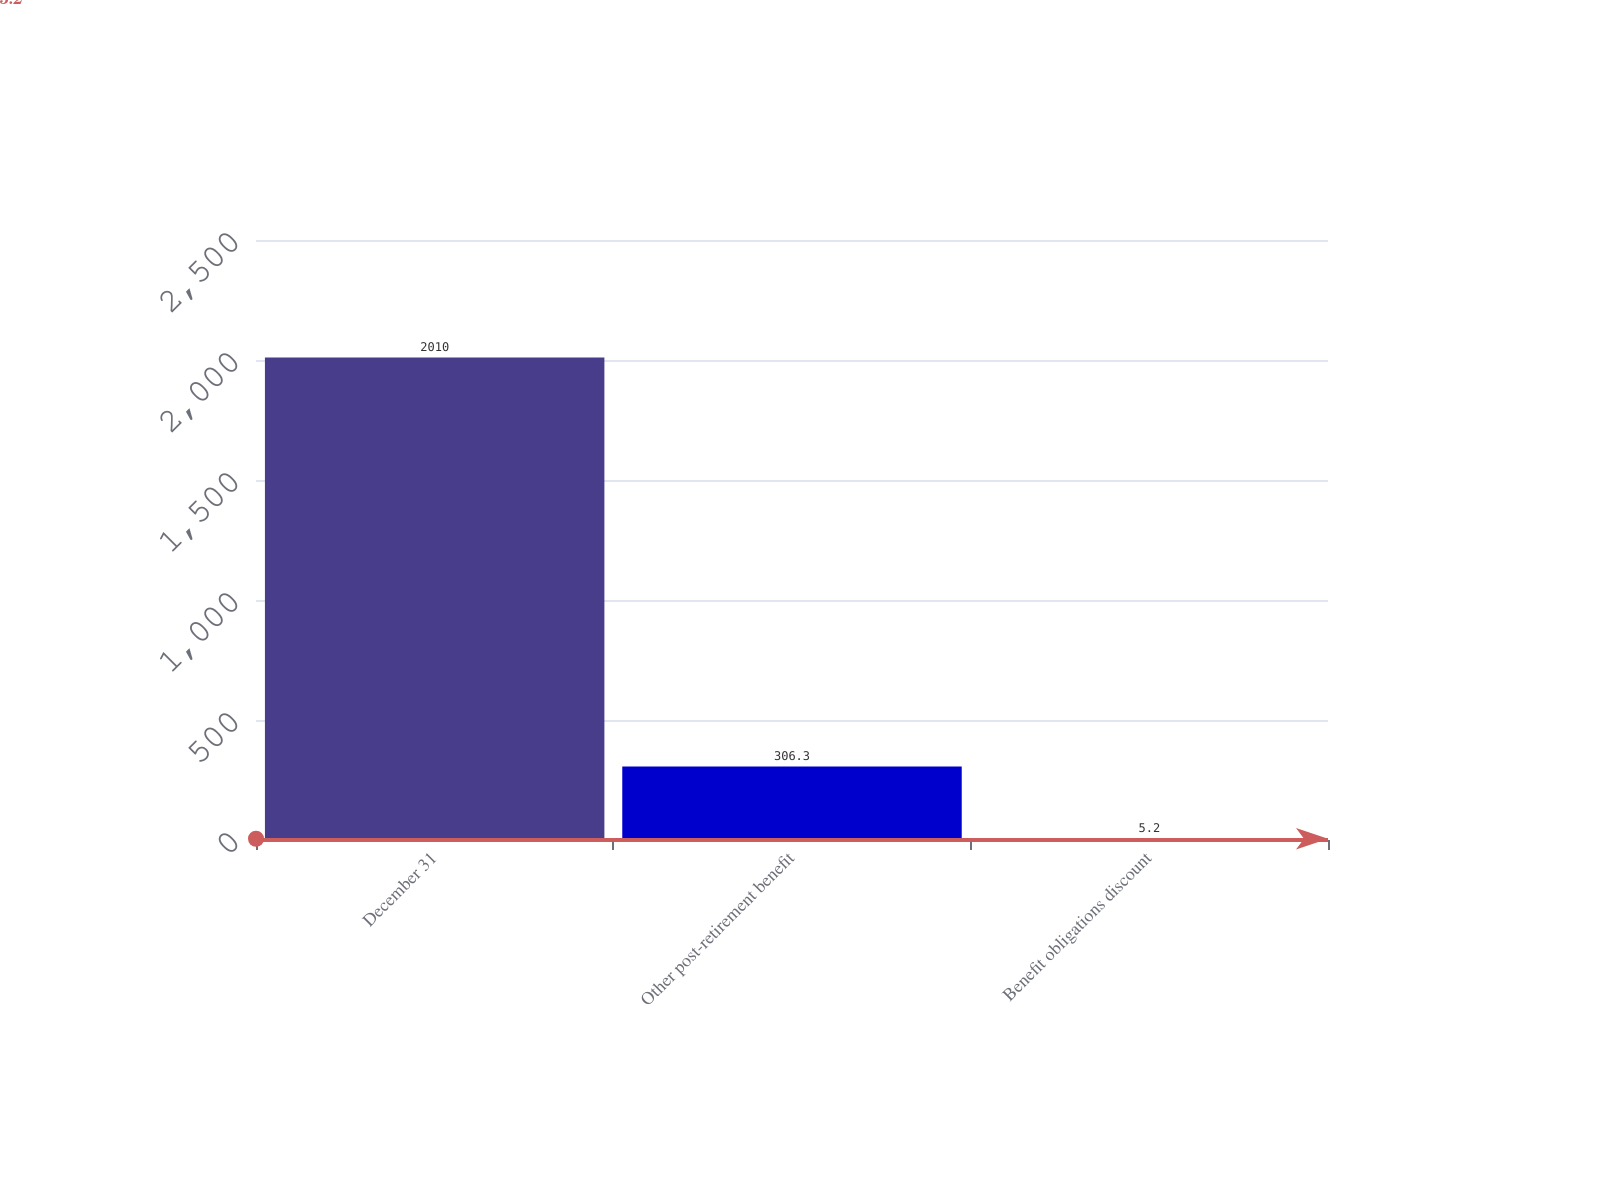Convert chart to OTSL. <chart><loc_0><loc_0><loc_500><loc_500><bar_chart><fcel>December 31<fcel>Other post-retirement benefit<fcel>Benefit obligations discount<nl><fcel>2010<fcel>306.3<fcel>5.2<nl></chart> 